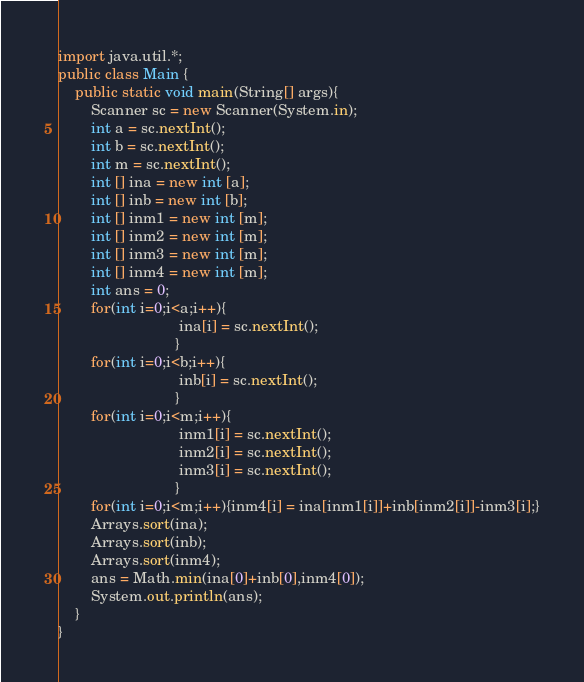<code> <loc_0><loc_0><loc_500><loc_500><_Java_>import java.util.*;
public class Main {
	public static void main(String[] args){
		Scanner sc = new Scanner(System.in);
		int a = sc.nextInt(); 
        int b = sc.nextInt();
		int m = sc.nextInt();
        int [] ina = new int [a];
        int [] inb = new int [b];
		int [] inm1 = new int [m];
        int [] inm2 = new int [m];
        int [] inm3 = new int [m];
        int [] inm4 = new int [m];
        int ans = 0;
        for(int i=0;i<a;i++){
                             ina[i] = sc.nextInt();
                            }
		for(int i=0;i<b;i++){
                             inb[i] = sc.nextInt();
                            }
        for(int i=0;i<m;i++){
                             inm1[i] = sc.nextInt();
                             inm2[i] = sc.nextInt();
                             inm3[i] = sc.nextInt();
                            }
        for(int i=0;i<m;i++){inm4[i] = ina[inm1[i]]+inb[inm2[i]]-inm3[i];}
        Arrays.sort(ina);
        Arrays.sort(inb);
        Arrays.sort(inm4);
        ans = Math.min(ina[0]+inb[0],inm4[0]);
		System.out.println(ans);
	}
}
</code> 